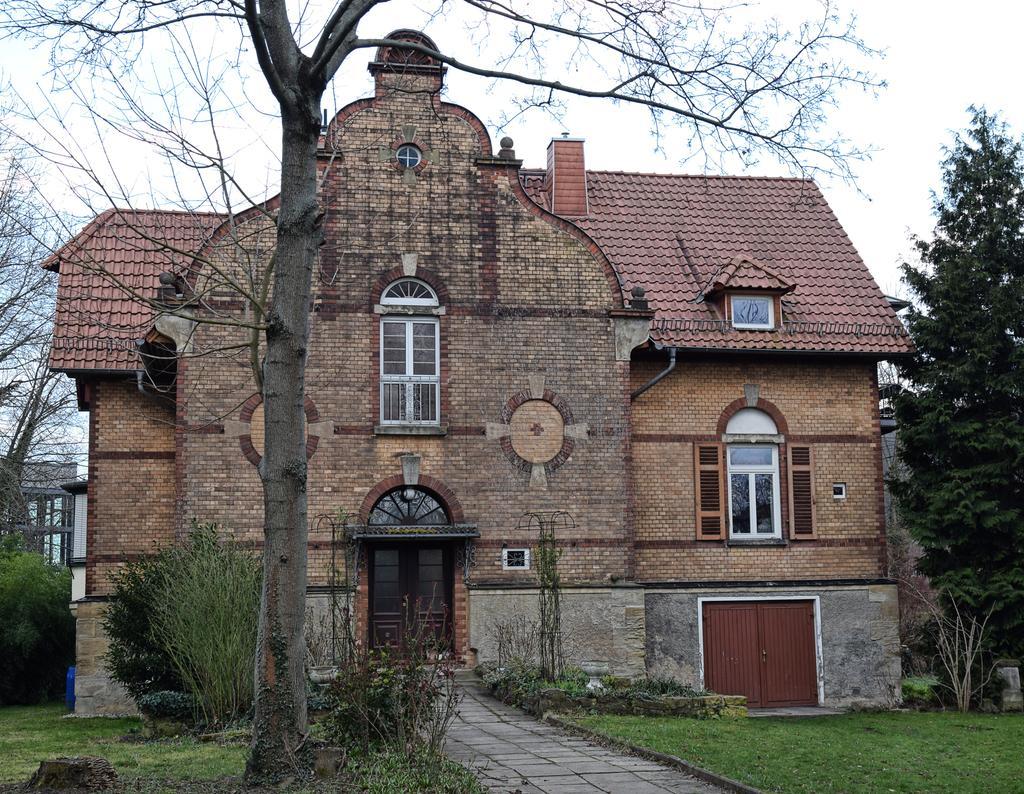In one or two sentences, can you explain what this image depicts? In the given picture, we can see a few tiny plants and the trunk of a tree, after that we can see the building included with windows, next we can see the way which leads to building entrance gate, finally towards the right, we can see the tree and a garden. 